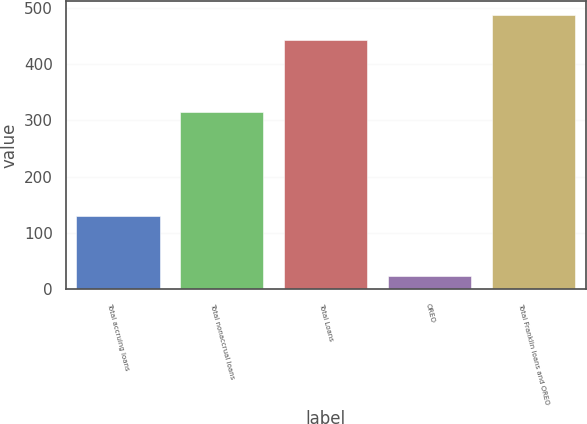Convert chart. <chart><loc_0><loc_0><loc_500><loc_500><bar_chart><fcel>Total accruing loans<fcel>Total nonaccrual loans<fcel>Total Loans<fcel>OREO<fcel>Total Franklin loans and OREO<nl><fcel>129.2<fcel>314.7<fcel>443.9<fcel>23.8<fcel>488.29<nl></chart> 